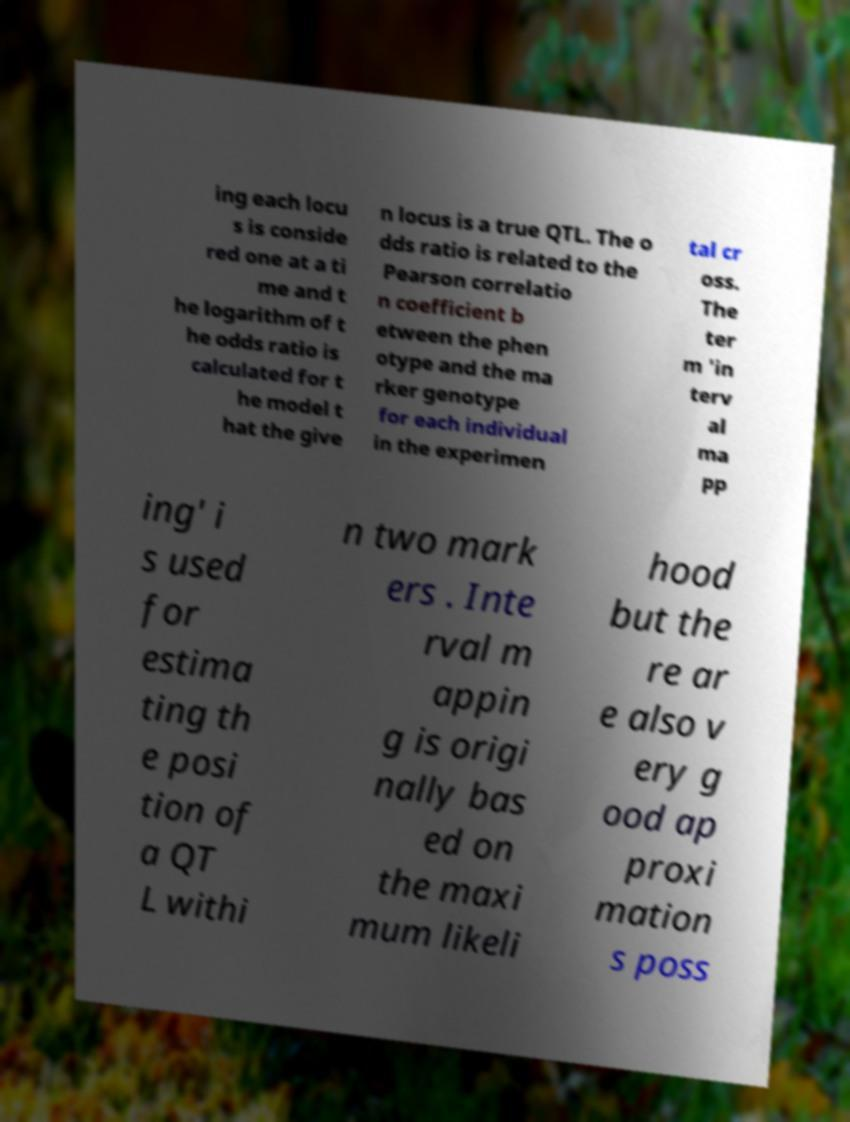Can you read and provide the text displayed in the image?This photo seems to have some interesting text. Can you extract and type it out for me? ing each locu s is conside red one at a ti me and t he logarithm of t he odds ratio is calculated for t he model t hat the give n locus is a true QTL. The o dds ratio is related to the Pearson correlatio n coefficient b etween the phen otype and the ma rker genotype for each individual in the experimen tal cr oss. The ter m 'in terv al ma pp ing' i s used for estima ting th e posi tion of a QT L withi n two mark ers . Inte rval m appin g is origi nally bas ed on the maxi mum likeli hood but the re ar e also v ery g ood ap proxi mation s poss 